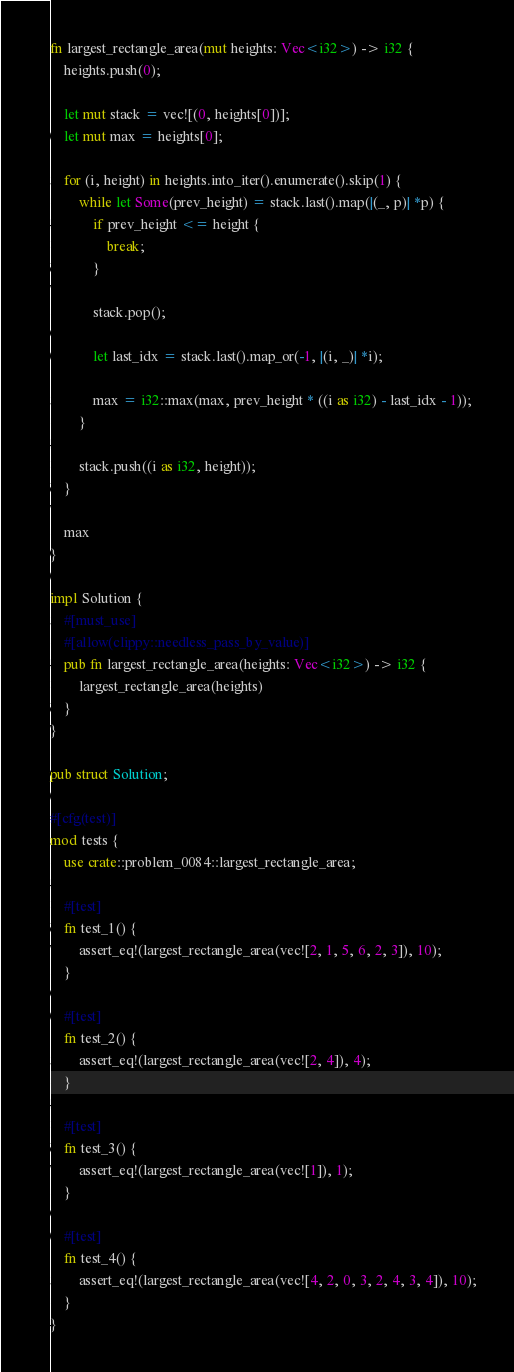Convert code to text. <code><loc_0><loc_0><loc_500><loc_500><_Rust_>fn largest_rectangle_area(mut heights: Vec<i32>) -> i32 {
    heights.push(0);

    let mut stack = vec![(0, heights[0])];
    let mut max = heights[0];

    for (i, height) in heights.into_iter().enumerate().skip(1) {
        while let Some(prev_height) = stack.last().map(|(_, p)| *p) {
            if prev_height <= height {
                break;
            }

            stack.pop();

            let last_idx = stack.last().map_or(-1, |(i, _)| *i);

            max = i32::max(max, prev_height * ((i as i32) - last_idx - 1));
        }

        stack.push((i as i32, height));
    }

    max
}

impl Solution {
    #[must_use]
    #[allow(clippy::needless_pass_by_value)]
    pub fn largest_rectangle_area(heights: Vec<i32>) -> i32 {
        largest_rectangle_area(heights)
    }
}

pub struct Solution;

#[cfg(test)]
mod tests {
    use crate::problem_0084::largest_rectangle_area;

    #[test]
    fn test_1() {
        assert_eq!(largest_rectangle_area(vec![2, 1, 5, 6, 2, 3]), 10);
    }

    #[test]
    fn test_2() {
        assert_eq!(largest_rectangle_area(vec![2, 4]), 4);
    }

    #[test]
    fn test_3() {
        assert_eq!(largest_rectangle_area(vec![1]), 1);
    }

    #[test]
    fn test_4() {
        assert_eq!(largest_rectangle_area(vec![4, 2, 0, 3, 2, 4, 3, 4]), 10);
    }
}
</code> 